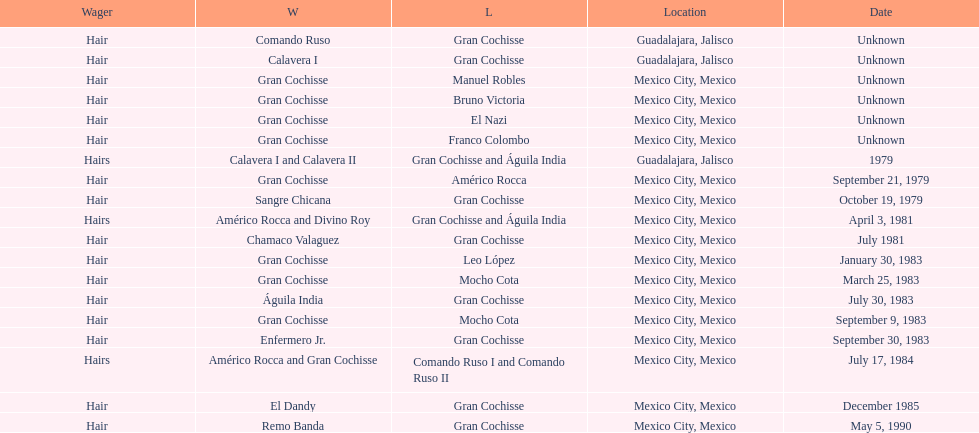When did bruno victoria lose his first game? Unknown. 